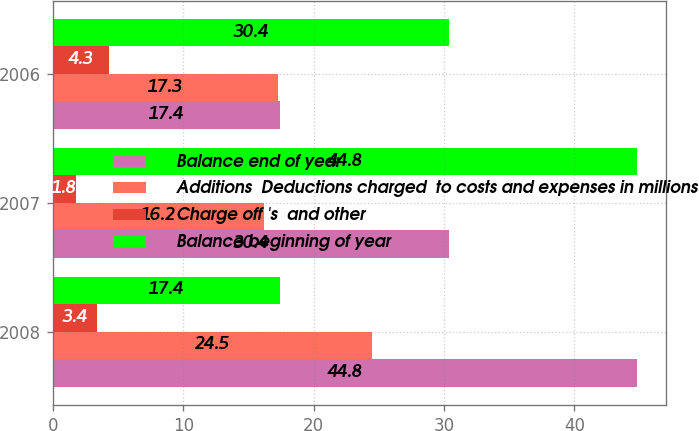Convert chart to OTSL. <chart><loc_0><loc_0><loc_500><loc_500><stacked_bar_chart><ecel><fcel>2008<fcel>2007<fcel>2006<nl><fcel>Balance end of year<fcel>44.8<fcel>30.4<fcel>17.4<nl><fcel>Additions  Deductions charged  to costs and expenses in millions<fcel>24.5<fcel>16.2<fcel>17.3<nl><fcel>Charge off 's  and other<fcel>3.4<fcel>1.8<fcel>4.3<nl><fcel>Balance beginning of year<fcel>17.4<fcel>44.8<fcel>30.4<nl></chart> 